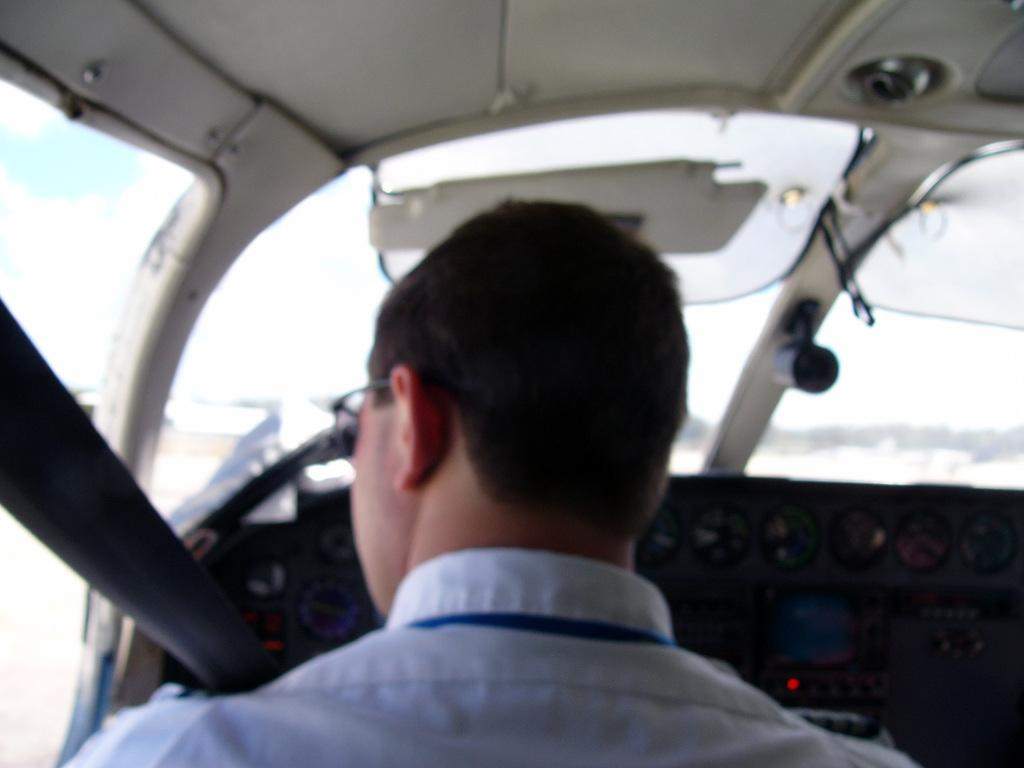Who or what is present in the image? There is a person in the image. What can be seen near the person? There is a control panel in the image. What type of material is used for the windows in the image? There are glass windows in the image. What is above the person and the control panel? There is a roof in the image. How many strings are attached to the person in the image? There are no strings attached to the person in the image. What type of cakes can be seen on the control panel? There are no cakes present in the image, and the control panel does not have any cakes on it. 